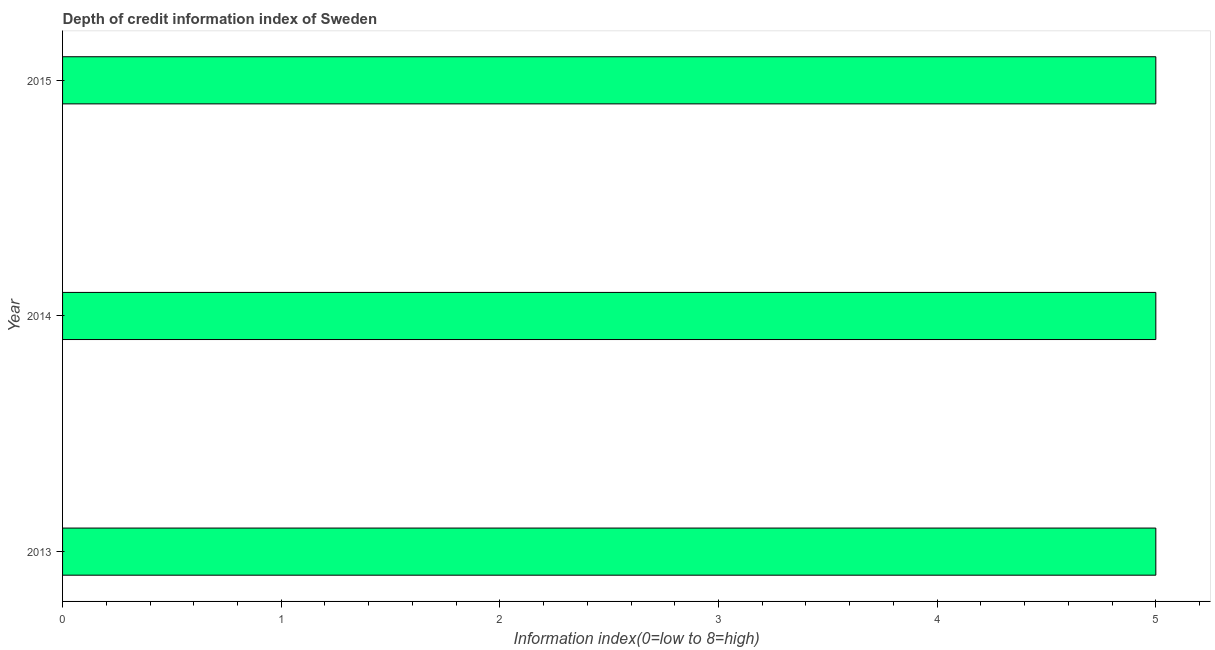Does the graph contain any zero values?
Provide a succinct answer. No. Does the graph contain grids?
Give a very brief answer. No. What is the title of the graph?
Make the answer very short. Depth of credit information index of Sweden. What is the label or title of the X-axis?
Keep it short and to the point. Information index(0=low to 8=high). What is the label or title of the Y-axis?
Offer a very short reply. Year. What is the depth of credit information index in 2014?
Make the answer very short. 5. In which year was the depth of credit information index maximum?
Keep it short and to the point. 2013. What is the difference between the depth of credit information index in 2013 and 2015?
Provide a short and direct response. 0. In how many years, is the depth of credit information index greater than 1.4 ?
Offer a very short reply. 3. Do a majority of the years between 2015 and 2013 (inclusive) have depth of credit information index greater than 1.6 ?
Provide a short and direct response. Yes. Is the depth of credit information index in 2013 less than that in 2015?
Your answer should be very brief. No. What is the difference between the highest and the second highest depth of credit information index?
Ensure brevity in your answer.  0. Is the sum of the depth of credit information index in 2014 and 2015 greater than the maximum depth of credit information index across all years?
Your answer should be compact. Yes. What is the difference between the highest and the lowest depth of credit information index?
Your response must be concise. 0. In how many years, is the depth of credit information index greater than the average depth of credit information index taken over all years?
Provide a succinct answer. 0. How many bars are there?
Your answer should be very brief. 3. Are all the bars in the graph horizontal?
Provide a short and direct response. Yes. How many years are there in the graph?
Provide a succinct answer. 3. What is the Information index(0=low to 8=high) in 2015?
Your answer should be very brief. 5. What is the difference between the Information index(0=low to 8=high) in 2013 and 2014?
Offer a terse response. 0. What is the difference between the Information index(0=low to 8=high) in 2013 and 2015?
Offer a very short reply. 0. What is the difference between the Information index(0=low to 8=high) in 2014 and 2015?
Your answer should be very brief. 0. 